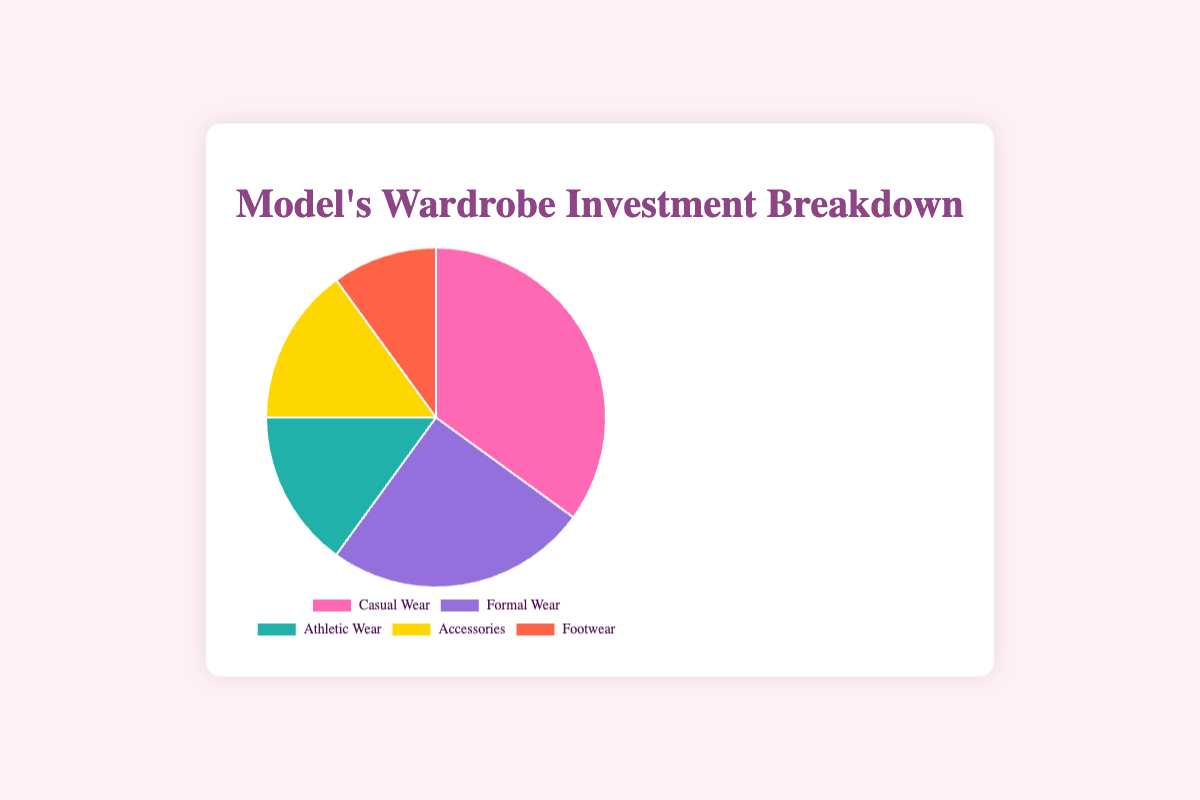What category has the largest investment? The largest segment in the pie chart represents the category with the highest percentage. Here it is the "Casual Wear" segment, occupying 35% of the pie.
Answer: Casual Wear Which categories have equal investments? The pie chart shows that "Athletic Wear" and "Accessories" each occupy the same percentage of the pie, at 15%.
Answer: Athletic Wear and Accessories What's the total investment percentage of non-casual categories combined? Adding up the percentages of "Formal Wear" (25%), "Athletic Wear" (15%), "Accessories" (15%), and "Footwear" (10%) will give the combined investment percentage. Thus, 25% + 15% + 15% + 10% = 65%.
Answer: 65% Is the investment in Footwear greater than Athletic Wear? From the pie chart, "Footwear" has a 10% investment, while "Athletic Wear" has a 15% investment. Hence, "Footwear" investment is not greater than "Athletic Wear".
Answer: No What is the difference in investment between Casual Wear and Formal Wear? The percentage for "Casual Wear" is 35%, and for "Formal Wear" it's 25%. The difference is 35% - 25% = 10%.
Answer: 10% What fraction of the investment is made up by Footwear? To find the fraction, take the investment percentage of "Footwear" which is 10% and convert it to a fraction: 10/100 = 1/10.
Answer: 1/10 What's the sum of investments in Casual Wear and Accessories? Adding the percentages of "Casual Wear" (35%) and "Accessories" (15%) gives 35% + 15% = 50%.
Answer: 50% If you combine the investments in Athletic Wear and Formal Wear, will it be more than Casual Wear? The sum of "Athletic Wear" (15%) and "Formal Wear" (25%) is 15% + 25% = 40%, which is less than "Casual Wear" at 35%.
Answer: No What is the color representation for the Accessories category? The "Accessories" segment in the pie chart is represented by the gold color.
Answer: Gold 